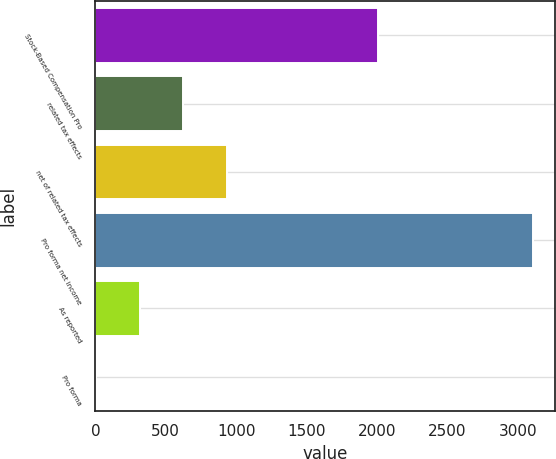Convert chart. <chart><loc_0><loc_0><loc_500><loc_500><bar_chart><fcel>Stock-Based Compensation Pro<fcel>related tax effects<fcel>net of related tax effects<fcel>Pro forma net income<fcel>As reported<fcel>Pro forma<nl><fcel>2005<fcel>625.45<fcel>936.14<fcel>3111<fcel>314.76<fcel>4.07<nl></chart> 